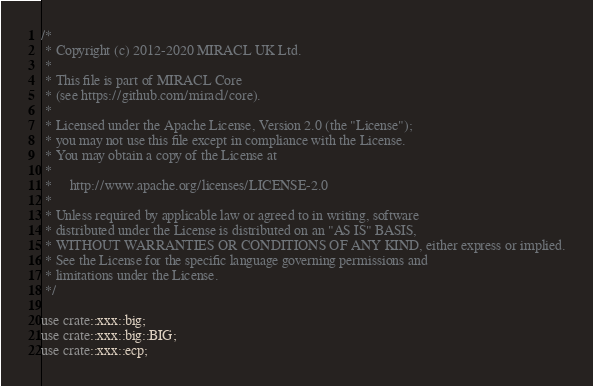<code> <loc_0><loc_0><loc_500><loc_500><_Rust_>/*
 * Copyright (c) 2012-2020 MIRACL UK Ltd.
 *
 * This file is part of MIRACL Core
 * (see https://github.com/miracl/core).
 *
 * Licensed under the Apache License, Version 2.0 (the "License");
 * you may not use this file except in compliance with the License.
 * You may obtain a copy of the License at
 *
 *     http://www.apache.org/licenses/LICENSE-2.0
 *
 * Unless required by applicable law or agreed to in writing, software
 * distributed under the License is distributed on an "AS IS" BASIS,
 * WITHOUT WARRANTIES OR CONDITIONS OF ANY KIND, either express or implied.
 * See the License for the specific language governing permissions and
 * limitations under the License.
 */

use crate::xxx::big;
use crate::xxx::big::BIG;
use crate::xxx::ecp;</code> 